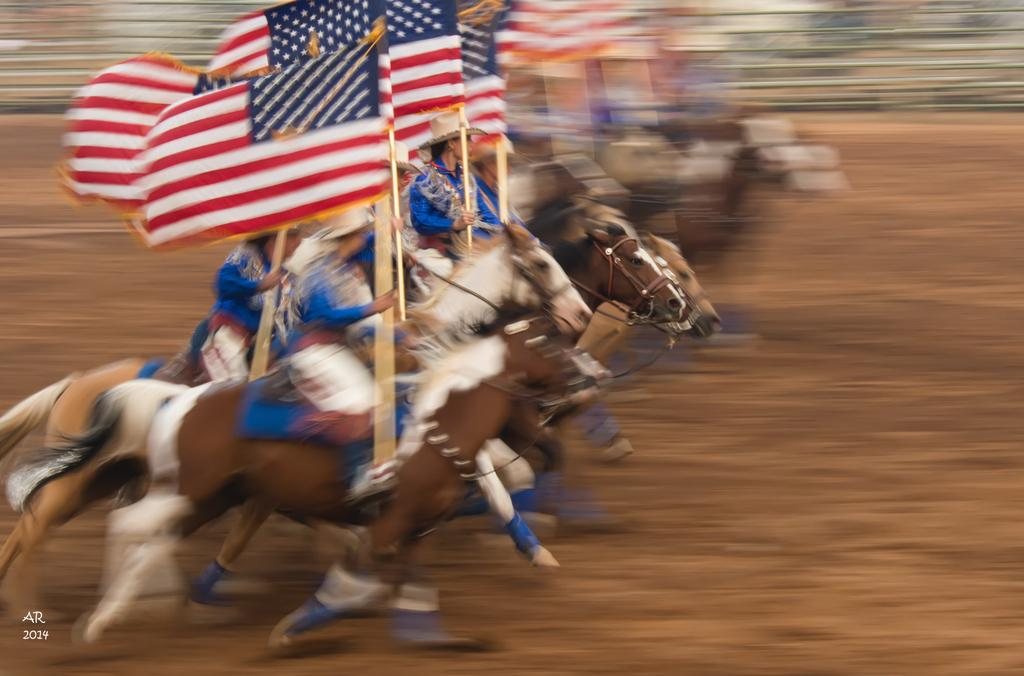What are the people in the image doing? The people in the image are riding horses. How are the people interacting with the horses? The people are sitting on the horses and holding onto the reins. What else are the people holding in the image? The people are holding poles and flags. Can you describe the background of the image? The background of the image is blurry. Is it raining in the image? There is no indication of rain in the image. Are the people sleeping on the horses in the image? The people are not sleeping on the horses; they are riding them. 